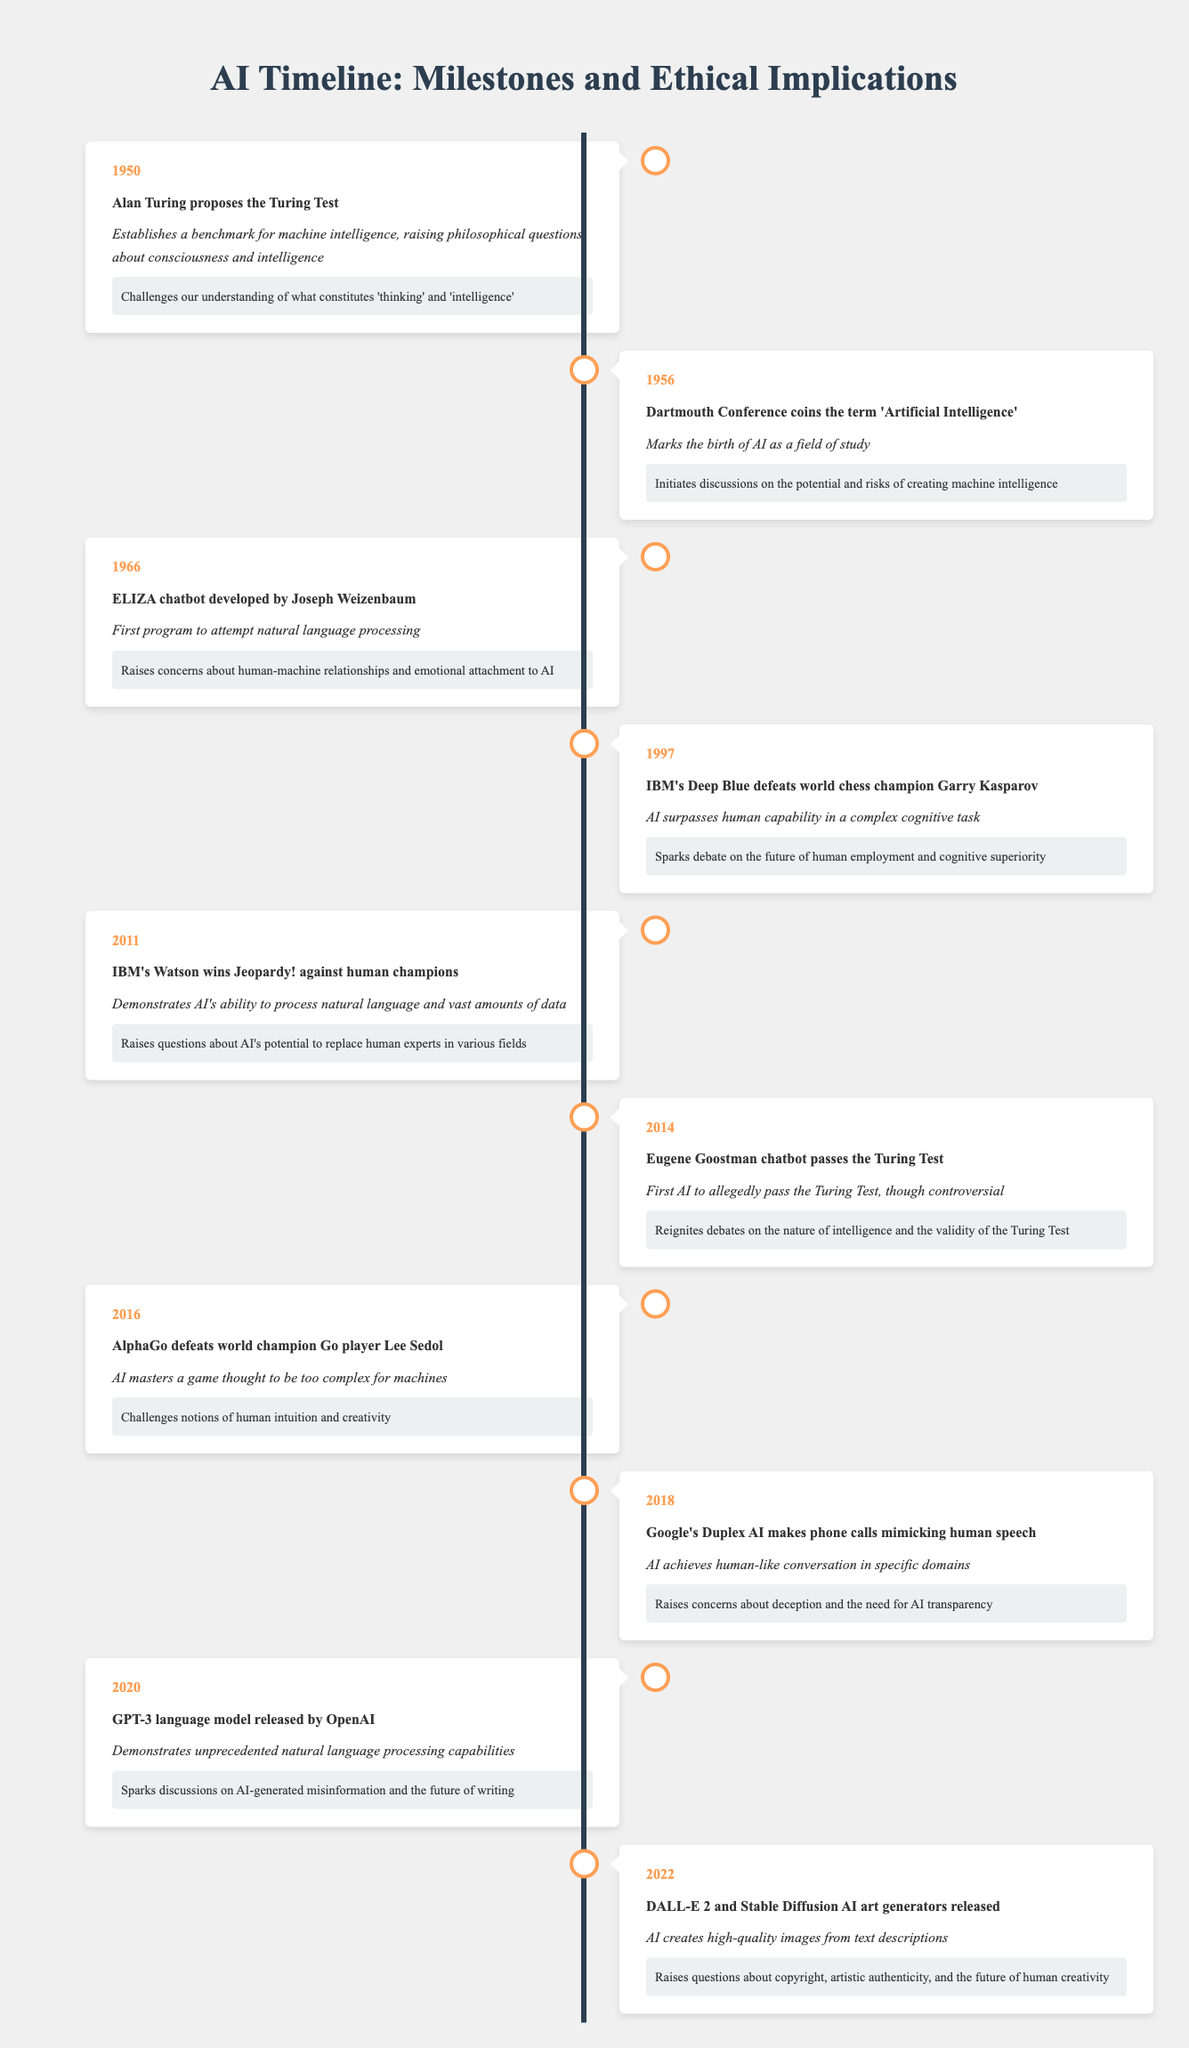What milestone occurred in 2011 related to AI? In 2011, IBM's Watson won Jeopardy! against human champions, demonstrating AI's ability to process natural language and vast amounts of data.
Answer: IBM's Watson wins Jeopardy! What was the significance of the 1997 event involving IBM's Deep Blue? The significance of this event is that AI surpassed human capability in a complex cognitive task by defeating world chess champion Garry Kasparov.
Answer: AI surpasses human capability How many events listed in the table raise ethical implications related to human employment? The events from 1997 (Deep Blue) and 2011 (Watson) both discuss concerns regarding human employment and cognitive superiority due to AI advancements. This totals to two events.
Answer: 2 Did Eugene Goostman passing the Turing Test in 2014 ignite debates on intelligence? Yes, it reignited debates on the nature of intelligence and the validity of the Turing Test, which was specifically mentioned as an ethical implication for that year.
Answer: Yes What are the years when AI advancements raised concerns about deception and transparency? The events in 2018 related to Google's Duplex AI making phone calls mimicking human speech explicitly mention concerns about deception and the need for AI transparency. Therefore, the year that raised such concerns is 2018.
Answer: 2018 What year marks the birth of AI as a field of study? The Dartmouth Conference in 1956 is noted as the point that coined the term 'Artificial Intelligence', marking its birth as a field of study.
Answer: 1956 Which two AI events from the timeline demonstrate advancements in natural language processing? The events in 1966 with the development of the ELIZA chatbot and in 2011 when IBM's Watson won Jeopardy! show significant advancements in natural language processing. This indicates a progression in AI's capabilities over time.
Answer: 1966 and 2011 Can AI art generators raise questions about artistic authenticity? Yes, the release of DALL-E 2 and Stable Diffusion in 2022 explicitly raises questions about copyright, artistic authenticity, and the future of human creativity.
Answer: Yes What was the ethical implication discussed in connection to AlphaGo's victory in 2016? The ethical implication of AlphaGo's victory is that it challenges notions of human intuition and creativity, as it was a game thought to be too complex for machines.
Answer: Challenges notions of intuition and creativity 